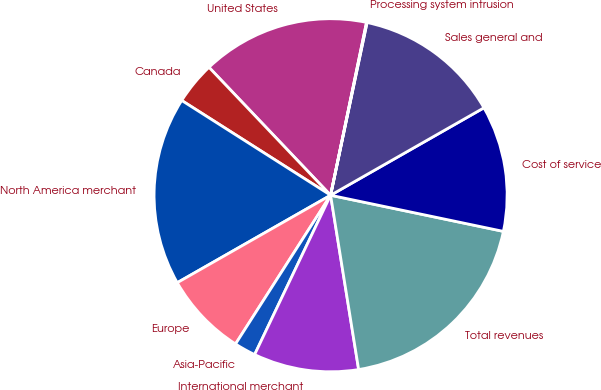<chart> <loc_0><loc_0><loc_500><loc_500><pie_chart><fcel>United States<fcel>Canada<fcel>North America merchant<fcel>Europe<fcel>Asia-Pacific<fcel>International merchant<fcel>Total revenues<fcel>Cost of service<fcel>Sales general and<fcel>Processing system intrusion<nl><fcel>15.36%<fcel>3.88%<fcel>17.27%<fcel>7.7%<fcel>1.97%<fcel>9.62%<fcel>19.18%<fcel>11.53%<fcel>13.44%<fcel>0.05%<nl></chart> 